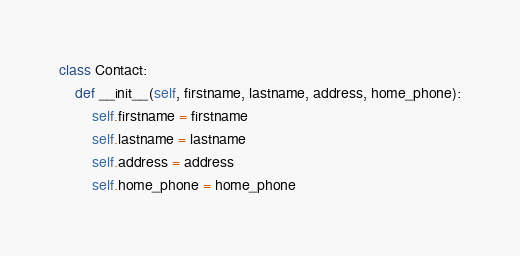<code> <loc_0><loc_0><loc_500><loc_500><_Python_>class Contact:
    def __init__(self, firstname, lastname, address, home_phone):
        self.firstname = firstname
        self.lastname = lastname
        self.address = address
        self.home_phone = home_phone</code> 